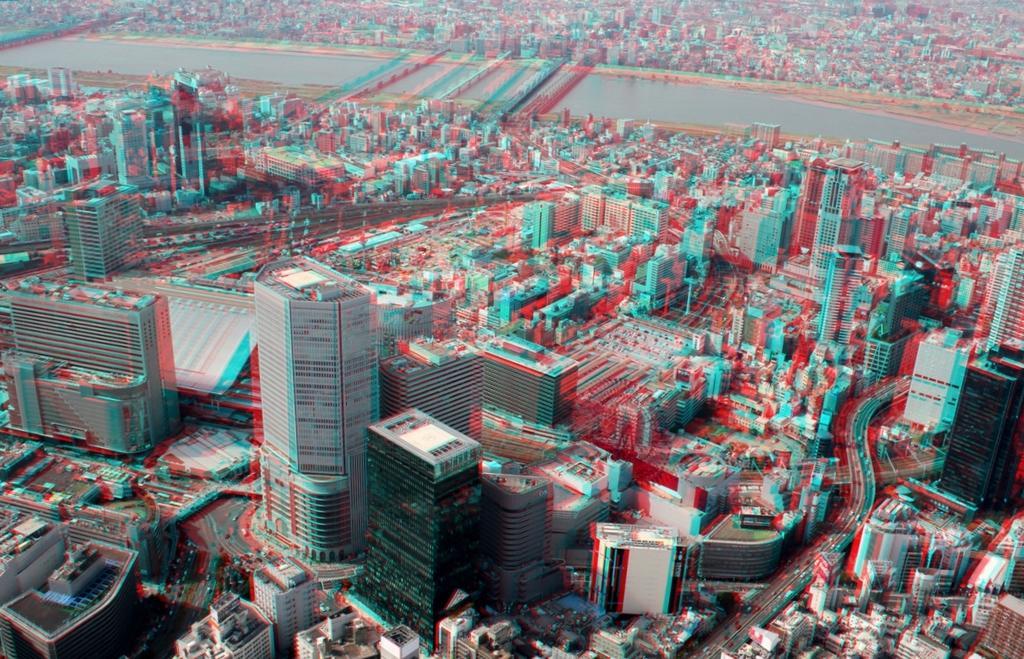Describe this image in one or two sentences. There are many buildings, vehicles on the roads and there is water at the back. 